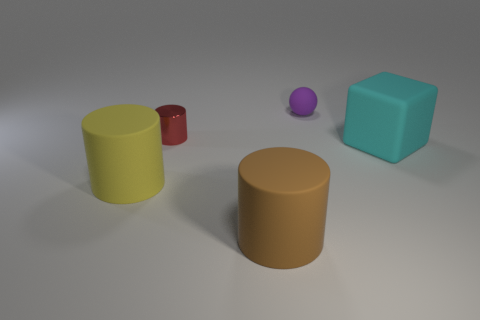There is a small red object that is the same shape as the large yellow matte object; what is its material?
Keep it short and to the point. Metal. There is a large matte object on the left side of the small red metallic cylinder; is it the same shape as the rubber object that is in front of the yellow matte cylinder?
Your answer should be compact. Yes. Are there any gray spheres?
Your response must be concise. No. What number of other objects are the same material as the small cylinder?
Provide a succinct answer. 0. There is another cylinder that is the same size as the brown matte cylinder; what material is it?
Your answer should be compact. Rubber. There is a small thing right of the big brown rubber object; does it have the same shape as the small red metallic object?
Provide a short and direct response. No. What number of things are large objects that are to the right of the big yellow matte cylinder or big cylinders?
Give a very brief answer. 3. There is a cyan matte thing that is the same size as the brown rubber thing; what is its shape?
Give a very brief answer. Cube. Do the cylinder that is behind the cyan rubber block and the thing behind the red metal object have the same size?
Offer a very short reply. Yes. There is a large cube that is the same material as the tiny purple object; what color is it?
Provide a short and direct response. Cyan. 